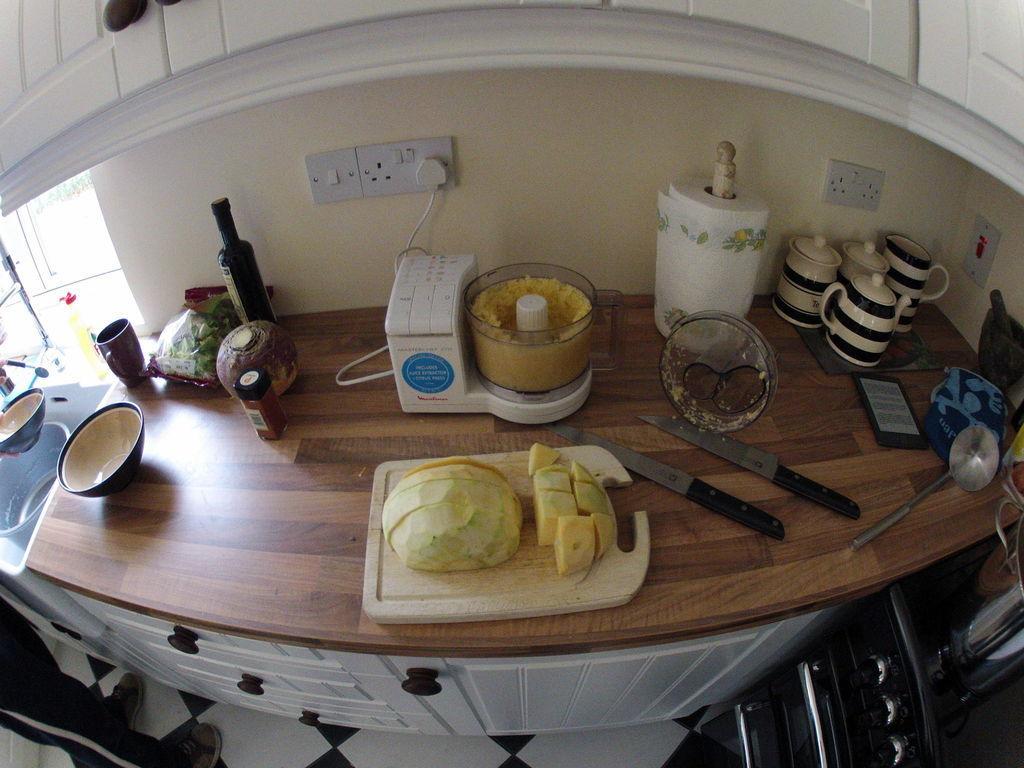Describe this image in one or two sentences. There is a vegetable item on the chopping pad, knives, ceramic utensils, bowl, mug and other kitchenware items in the foreground, there are cupboards at the top and bottom of the image, it seems like a window and sink on the left side. 